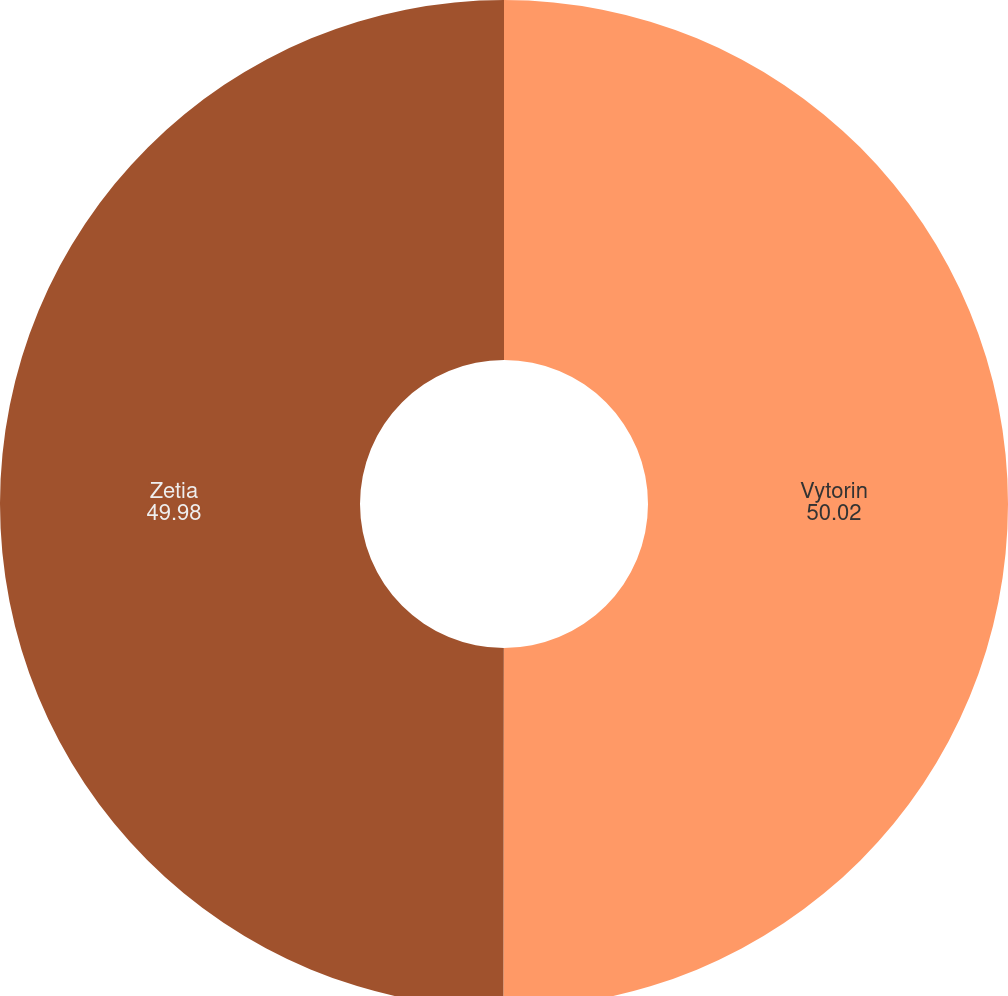<chart> <loc_0><loc_0><loc_500><loc_500><pie_chart><fcel>Vytorin<fcel>Zetia<nl><fcel>50.02%<fcel>49.98%<nl></chart> 